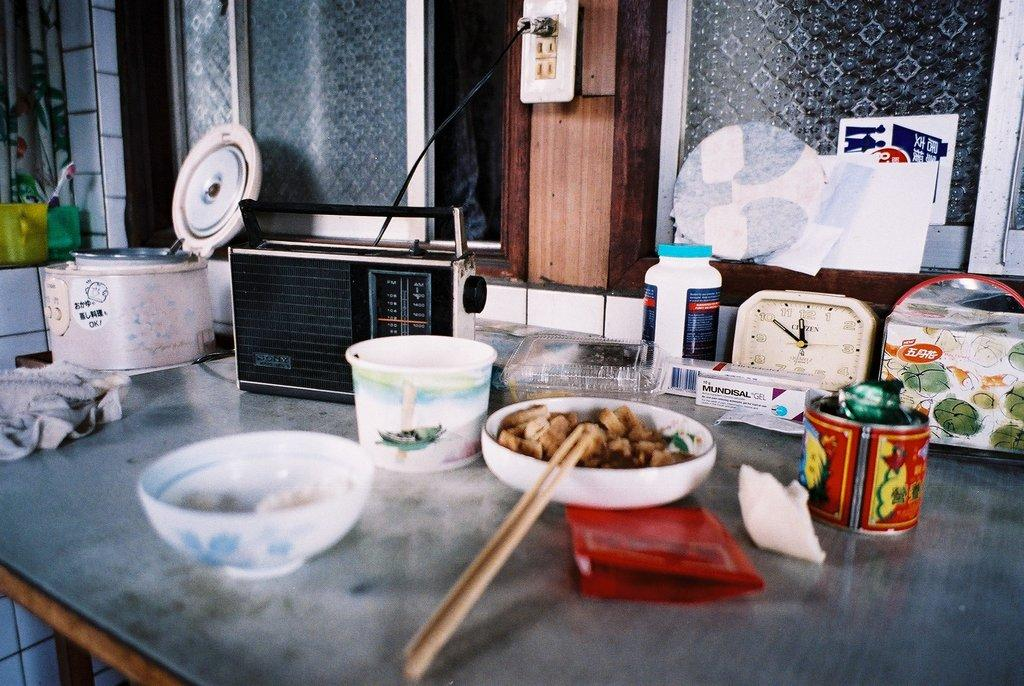What piece of furniture is present in the image? There is a table in the image. What is on top of the table? There is a bowl, a radio, a cooker, and a watch on the table. What type of window can be seen in the image? There is a glass window in the image. What caption is written on the cooker in the image? There is no caption written on the cooker in the image. Can you see a bed in the image? There is no bed present in the image. 